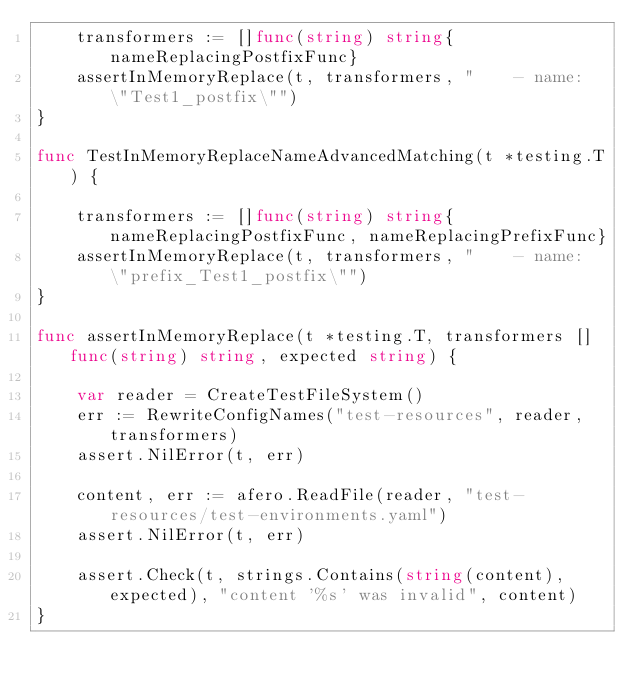<code> <loc_0><loc_0><loc_500><loc_500><_Go_>	transformers := []func(string) string{nameReplacingPostfixFunc}
	assertInMemoryReplace(t, transformers, "    - name: \"Test1_postfix\"")
}

func TestInMemoryReplaceNameAdvancedMatching(t *testing.T) {

	transformers := []func(string) string{nameReplacingPostfixFunc, nameReplacingPrefixFunc}
	assertInMemoryReplace(t, transformers, "    - name: \"prefix_Test1_postfix\"")
}

func assertInMemoryReplace(t *testing.T, transformers []func(string) string, expected string) {

	var reader = CreateTestFileSystem()
	err := RewriteConfigNames("test-resources", reader, transformers)
	assert.NilError(t, err)

	content, err := afero.ReadFile(reader, "test-resources/test-environments.yaml")
	assert.NilError(t, err)

	assert.Check(t, strings.Contains(string(content), expected), "content '%s' was invalid", content)
}
</code> 